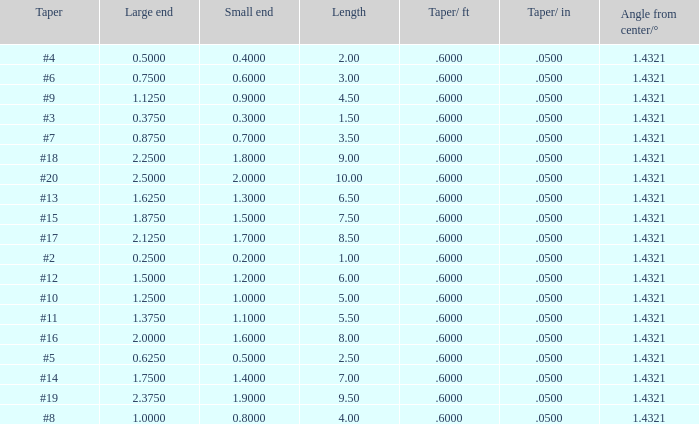Could you parse the entire table as a dict? {'header': ['Taper', 'Large end', 'Small end', 'Length', 'Taper/ ft', 'Taper/ in', 'Angle from center/°'], 'rows': [['#4', '0.5000', '0.4000', '2.00', '.6000', '.0500', '1.4321'], ['#6', '0.7500', '0.6000', '3.00', '.6000', '.0500', '1.4321'], ['#9', '1.1250', '0.9000', '4.50', '.6000', '.0500', '1.4321'], ['#3', '0.3750', '0.3000', '1.50', '.6000', '.0500', '1.4321'], ['#7', '0.8750', '0.7000', '3.50', '.6000', '.0500', '1.4321'], ['#18', '2.2500', '1.8000', '9.00', '.6000', '.0500', '1.4321'], ['#20', '2.5000', '2.0000', '10.00', '.6000', '.0500', '1.4321'], ['#13', '1.6250', '1.3000', '6.50', '.6000', '.0500', '1.4321'], ['#15', '1.8750', '1.5000', '7.50', '.6000', '.0500', '1.4321'], ['#17', '2.1250', '1.7000', '8.50', '.6000', '.0500', '1.4321'], ['#2', '0.2500', '0.2000', '1.00', '.6000', '.0500', '1.4321'], ['#12', '1.5000', '1.2000', '6.00', '.6000', '.0500', '1.4321'], ['#10', '1.2500', '1.0000', '5.00', '.6000', '.0500', '1.4321'], ['#11', '1.3750', '1.1000', '5.50', '.6000', '.0500', '1.4321'], ['#16', '2.0000', '1.6000', '8.00', '.6000', '.0500', '1.4321'], ['#5', '0.6250', '0.5000', '2.50', '.6000', '.0500', '1.4321'], ['#14', '1.7500', '1.4000', '7.00', '.6000', '.0500', '1.4321'], ['#19', '2.3750', '1.9000', '9.50', '.6000', '.0500', '1.4321'], ['#8', '1.0000', '0.8000', '4.00', '.6000', '.0500', '1.4321']]} Which Taper/in that has a Small end larger than 0.7000000000000001, and a Taper of #19, and a Large end larger than 2.375? None. 